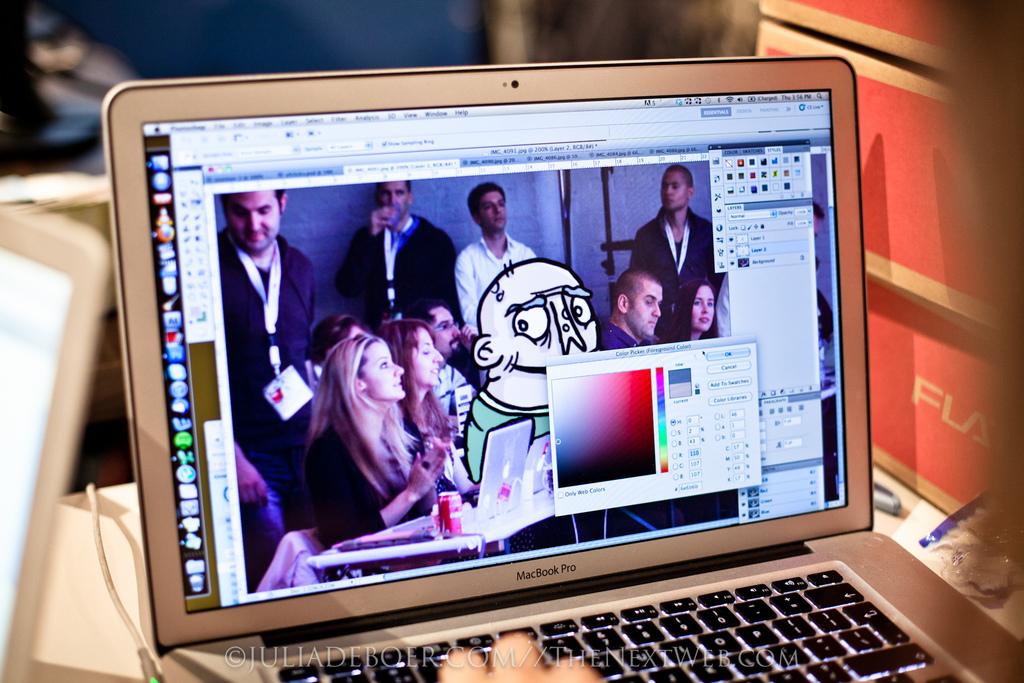What kind of laptop is this?
Offer a terse response. Macbook pro. 